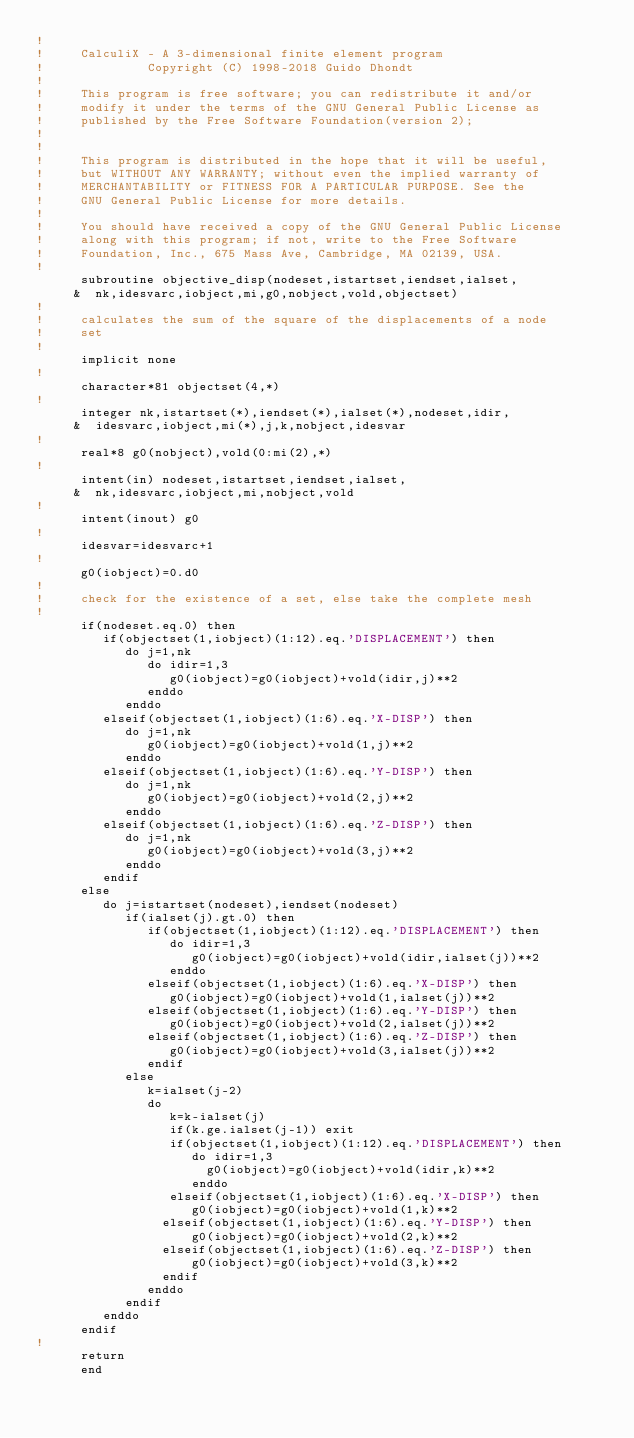Convert code to text. <code><loc_0><loc_0><loc_500><loc_500><_FORTRAN_>!
!     CalculiX - A 3-dimensional finite element program
!              Copyright (C) 1998-2018 Guido Dhondt
!
!     This program is free software; you can redistribute it and/or
!     modify it under the terms of the GNU General Public License as
!     published by the Free Software Foundation(version 2);
!     
!
!     This program is distributed in the hope that it will be useful,
!     but WITHOUT ANY WARRANTY; without even the implied warranty of 
!     MERCHANTABILITY or FITNESS FOR A PARTICULAR PURPOSE. See the 
!     GNU General Public License for more details.
!
!     You should have received a copy of the GNU General Public License
!     along with this program; if not, write to the Free Software
!     Foundation, Inc., 675 Mass Ave, Cambridge, MA 02139, USA.
!
      subroutine objective_disp(nodeset,istartset,iendset,ialset,
     &  nk,idesvarc,iobject,mi,g0,nobject,vold,objectset)
!
!     calculates the sum of the square of the displacements of a node
!     set
!
      implicit none
!
      character*81 objectset(4,*)
!
      integer nk,istartset(*),iendset(*),ialset(*),nodeset,idir,
     &  idesvarc,iobject,mi(*),j,k,nobject,idesvar
!
      real*8 g0(nobject),vold(0:mi(2),*)
!
      intent(in) nodeset,istartset,iendset,ialset,
     &  nk,idesvarc,iobject,mi,nobject,vold
!
      intent(inout) g0
!
      idesvar=idesvarc+1
!
      g0(iobject)=0.d0
!
!     check for the existence of a set, else take the complete mesh
!
      if(nodeset.eq.0) then
         if(objectset(1,iobject)(1:12).eq.'DISPLACEMENT') then
            do j=1,nk           
               do idir=1,3
                  g0(iobject)=g0(iobject)+vold(idir,j)**2
               enddo      
            enddo
         elseif(objectset(1,iobject)(1:6).eq.'X-DISP') then
            do j=1,nk           
               g0(iobject)=g0(iobject)+vold(1,j)**2      
            enddo
         elseif(objectset(1,iobject)(1:6).eq.'Y-DISP') then
            do j=1,nk           
               g0(iobject)=g0(iobject)+vold(2,j)**2      
            enddo
         elseif(objectset(1,iobject)(1:6).eq.'Z-DISP') then
            do j=1,nk           
               g0(iobject)=g0(iobject)+vold(3,j)**2      
            enddo
         endif
      else
         do j=istartset(nodeset),iendset(nodeset)
            if(ialset(j).gt.0) then
               if(objectset(1,iobject)(1:12).eq.'DISPLACEMENT') then
                  do idir=1,3
                     g0(iobject)=g0(iobject)+vold(idir,ialset(j))**2
                  enddo    
               elseif(objectset(1,iobject)(1:6).eq.'X-DISP') then  
                  g0(iobject)=g0(iobject)+vold(1,ialset(j))**2
               elseif(objectset(1,iobject)(1:6).eq.'Y-DISP') then  
                  g0(iobject)=g0(iobject)+vold(2,ialset(j))**2
               elseif(objectset(1,iobject)(1:6).eq.'Z-DISP') then  
                  g0(iobject)=g0(iobject)+vold(3,ialset(j))**2
               endif
            else
               k=ialset(j-2)
               do
                  k=k-ialset(j)
                  if(k.ge.ialset(j-1)) exit
                  if(objectset(1,iobject)(1:12).eq.'DISPLACEMENT') then
                     do idir=1,3
                       g0(iobject)=g0(iobject)+vold(idir,k)**2
                     enddo     
                  elseif(objectset(1,iobject)(1:6).eq.'X-DISP') then     
                     g0(iobject)=g0(iobject)+vold(1,k)**2
                 elseif(objectset(1,iobject)(1:6).eq.'Y-DISP') then     
                     g0(iobject)=g0(iobject)+vold(2,k)**2
                 elseif(objectset(1,iobject)(1:6).eq.'Z-DISP') then     
                     g0(iobject)=g0(iobject)+vold(3,k)**2
                 endif
               enddo
            endif
         enddo
      endif
!     
      return
      end
      
</code> 